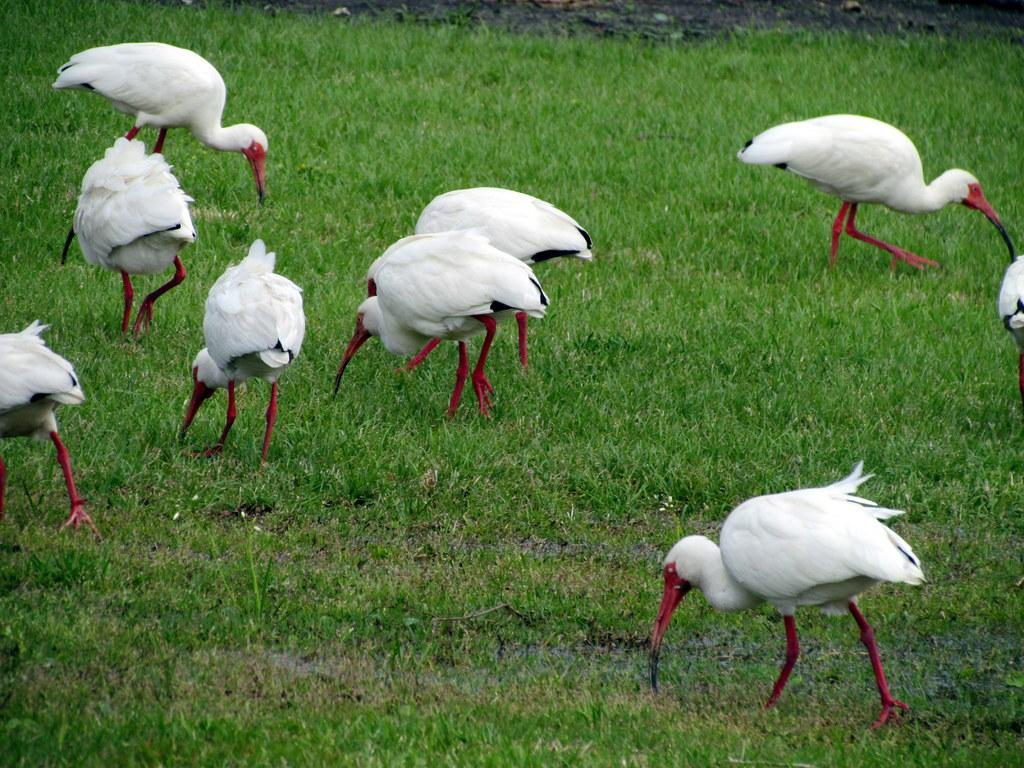What type of animals can be seen in the image? There are birds visible in the image. Where are the birds located? The birds are on grass. What type of rail can be seen in the image? There is no rail present in the image; it features birds on grass. What type of cannon is being used by the birds in the image? There is no cannon present in the image, and birds do not use cannons. 